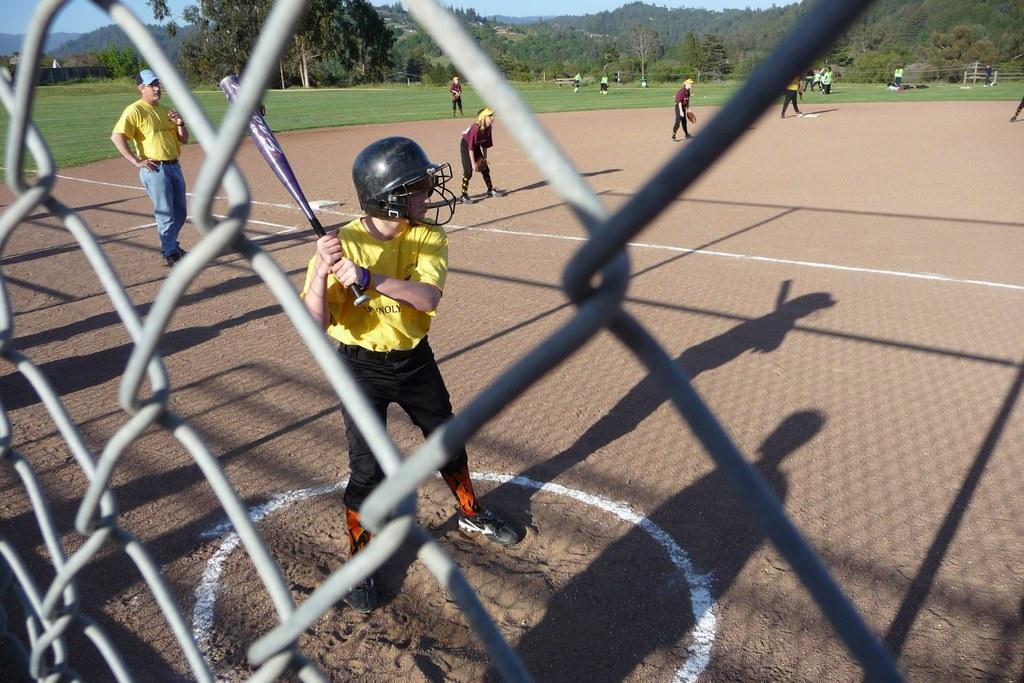In one or two sentences, can you explain what this image depicts? In this image we can see few people wearing sports dress and playing and among them one boy holding a baseball bat and we can see the fence. There are some trees and grass on the ground. 